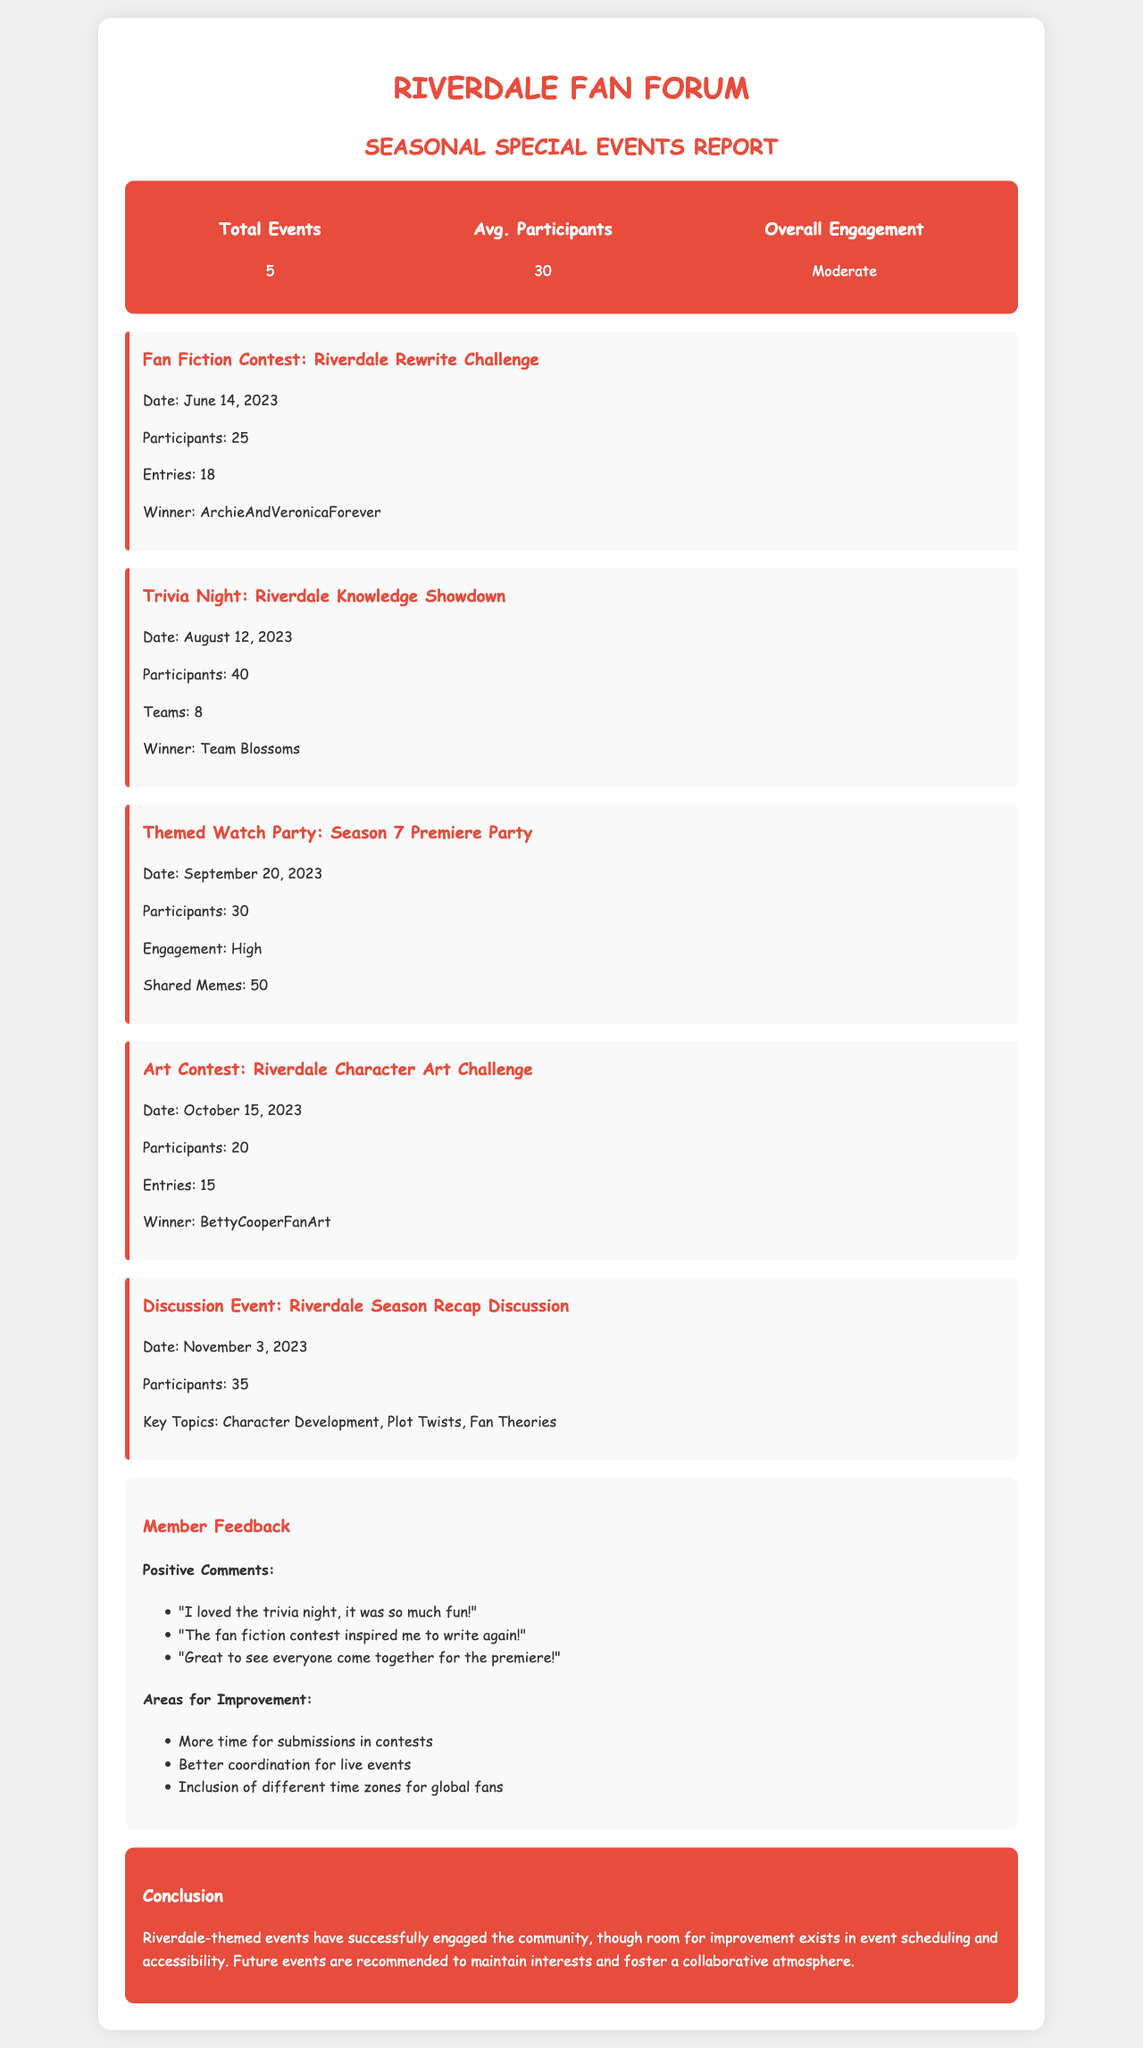What was the date of the Fan Fiction Contest? The date of the Fan Fiction Contest is mentioned as June 14, 2023.
Answer: June 14, 2023 How many participants joined the Trivia Night? The number of participants in the Trivia Night is stated to be 40.
Answer: 40 Who won the Art Contest? The winner of the Art Contest is specified as BettyCooperFanArt.
Answer: BettyCooperFanArt What was the overall engagement level for the events? The document notes that the overall engagement for the events was moderate.
Answer: Moderate Which event had the highest engagement? The event with the highest engagement is noted to be the Themed Watch Party.
Answer: Themed Watch Party What feedback was given regarding submission time? The document mentions that there was feedback requesting more time for submissions in contests.
Answer: More time for submissions in contests How many total events were held? The total number of events is indicated to be 5.
Answer: 5 What were the key topics discussed in the Recap Discussion? The key topics for the Recap Discussion are stated as Character Development, Plot Twists, and Fan Theories.
Answer: Character Development, Plot Twists, Fan Theories 